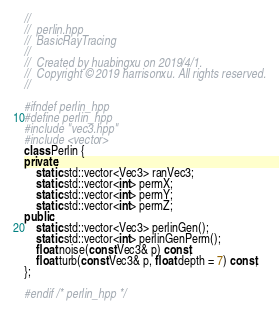Convert code to text. <code><loc_0><loc_0><loc_500><loc_500><_C++_>//
//  perlin.hpp
//  BasicRayTracing
//
//  Created by huabingxu on 2019/4/1.
//  Copyright © 2019 harrisonxu. All rights reserved.
//

#ifndef perlin_hpp
#define perlin_hpp
#include "vec3.hpp"
#include <vector>
class Perlin {
private:
    static std::vector<Vec3> ranVec3;
    static std::vector<int> permX;
    static std::vector<int> permY;
    static std::vector<int> permZ;
public:
    static std::vector<Vec3> perlinGen();
    static std::vector<int> perlinGenPerm();
    float noise(const Vec3& p) const;
    float turb(const Vec3& p, float depth = 7) const;
};

#endif /* perlin_hpp */
</code> 